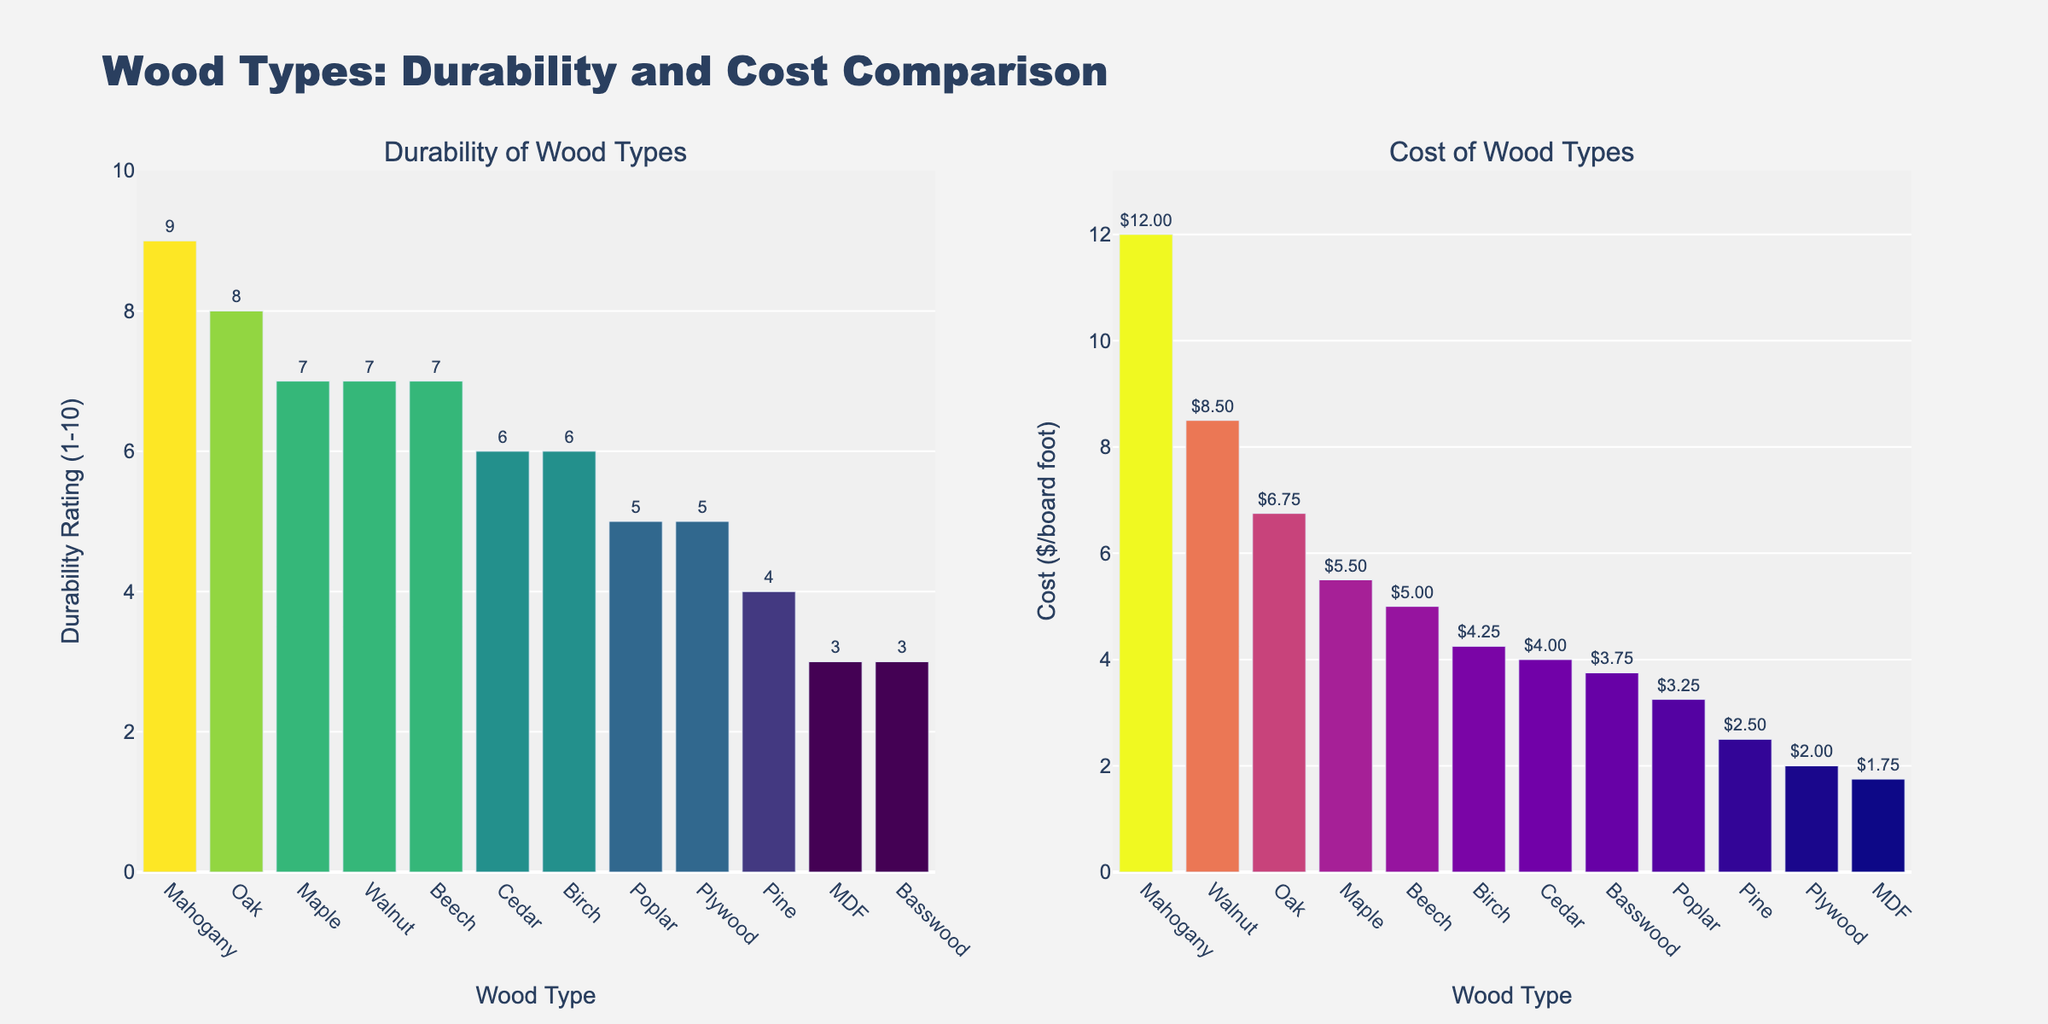What's the most durable wood according to the figure? The most durable wood is the one with the highest durability rating. By examining the durability subplot, we see that Mahogany has the highest bar at 9.
Answer: Mahogany Which wood type has the lowest cost per board foot? The lowest cost per board foot can be identified by finding the shortest bar in the cost subplot. MDF has the smallest bar at $1.75.
Answer: MDF What's the average durability rating of Beech and Birch? Locate the durability ratings of Beech (7) and Birch (6) in the durability subplot. The average is calculated as (7 + 6) / 2 = 6.5.
Answer: 6.5 Which are the only two wood types with the same durability rating? Checking the durability subplot, Birch and Cedar both have a durability rating of 6, the only duplicated value.
Answer: Birch and Cedar How much more expensive is Mahogany compared to Pine per board foot? From the cost subplot, Mahogany costs $12.00 and Pine costs $2.50. Subtract the cost of Pine from Mahogany: $12.00 - $2.50 = $9.50.
Answer: $9.50 Between Oak and Walnut, which has a higher durability rating and what is the difference? From the durability subplot, Oak has a rating of 8 and Walnut has a rating of 7. The difference is 8 - 7 = 1. Oak has a higher durability.
Answer: Oak, 1 What is the total cost of one board foot of Pine, Poplar, and MDF combined? Sum the costs of Pine ($2.50), Poplar ($3.25), and MDF ($1.75) from the cost subplot: $2.50 + $3.25 + $1.75 = $7.50.
Answer: $7.50 Which wood type has the lowest durability but is more expensive than Pine per board foot? Pine has a durability of 4 and costs $2.50 per board foot. The wood with the lowest durability is MDF (3) and costs $1.75, which is cheaper. Hence, Basswood with a durability of 3 and cost $3.75 is the answer.
Answer: Basswood 